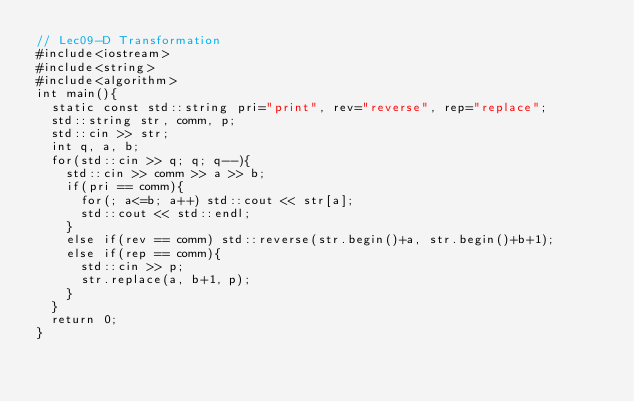Convert code to text. <code><loc_0><loc_0><loc_500><loc_500><_C++_>// Lec09-D Transformation
#include<iostream>
#include<string>
#include<algorithm>
int main(){
  static const std::string pri="print", rev="reverse", rep="replace";
  std::string str, comm, p;
  std::cin >> str;
  int q, a, b;
  for(std::cin >> q; q; q--){
    std::cin >> comm >> a >> b;
    if(pri == comm){
      for(; a<=b; a++) std::cout << str[a];
      std::cout << std::endl;
    }
    else if(rev == comm) std::reverse(str.begin()+a, str.begin()+b+1);
    else if(rep == comm){
      std::cin >> p;
      str.replace(a, b+1, p);
    }
  }
  return 0;
}</code> 